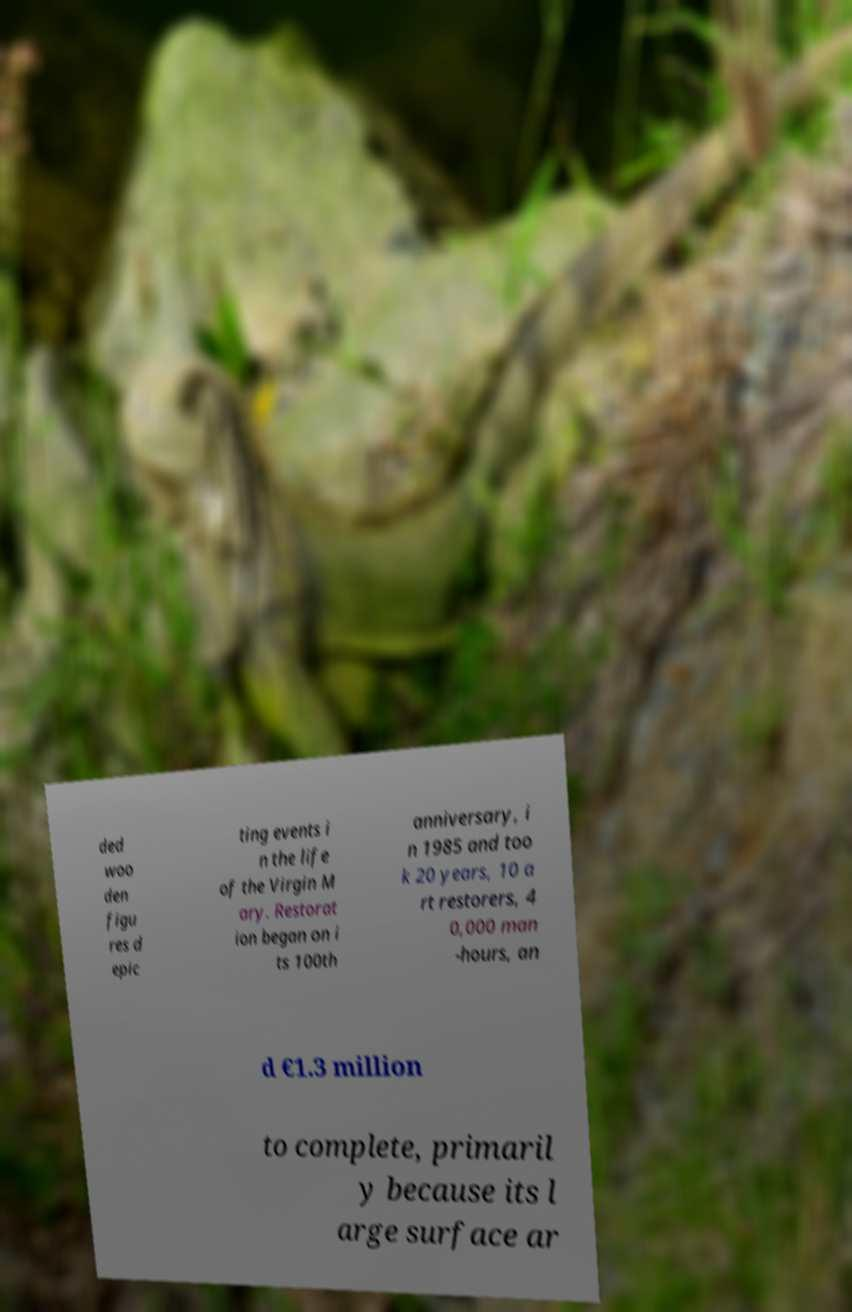For documentation purposes, I need the text within this image transcribed. Could you provide that? ded woo den figu res d epic ting events i n the life of the Virgin M ary. Restorat ion began on i ts 100th anniversary, i n 1985 and too k 20 years, 10 a rt restorers, 4 0,000 man -hours, an d €1.3 million to complete, primaril y because its l arge surface ar 